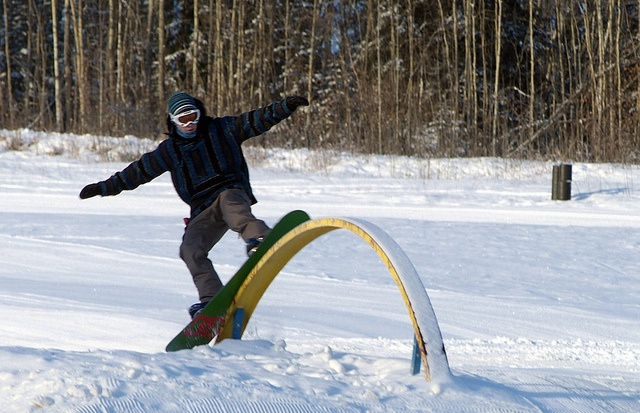Describe the objects in this image and their specific colors. I can see people in black, gray, and lightgray tones and snowboard in black, darkgreen, maroon, and gray tones in this image. 